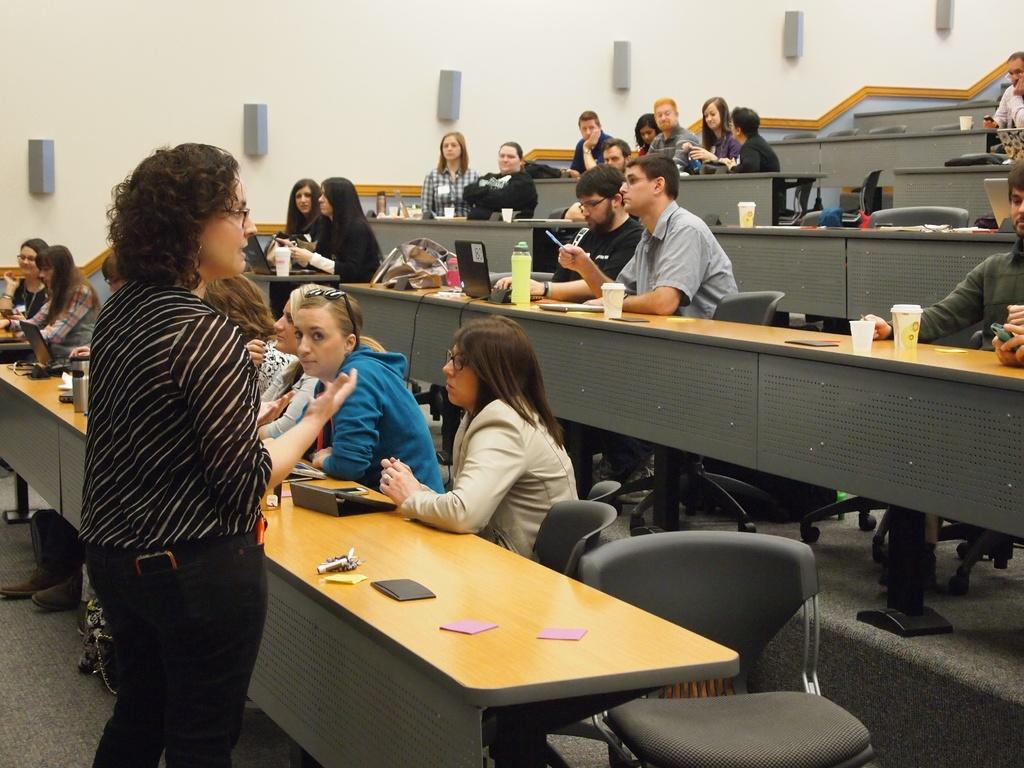Who is the main subject in the image? There is a woman in the image. What is the woman doing in the image? The woman is giving a lecture. Where is the lecture taking place? The lecture is taking place in a classroom. What are the students doing in the image? The students are sitting in benches and listening to the lecture. What type of vessel is being used by the students to carry their sugar during the lecture? There is no vessel or sugar present in the image; the students are simply listening to the lecture. 